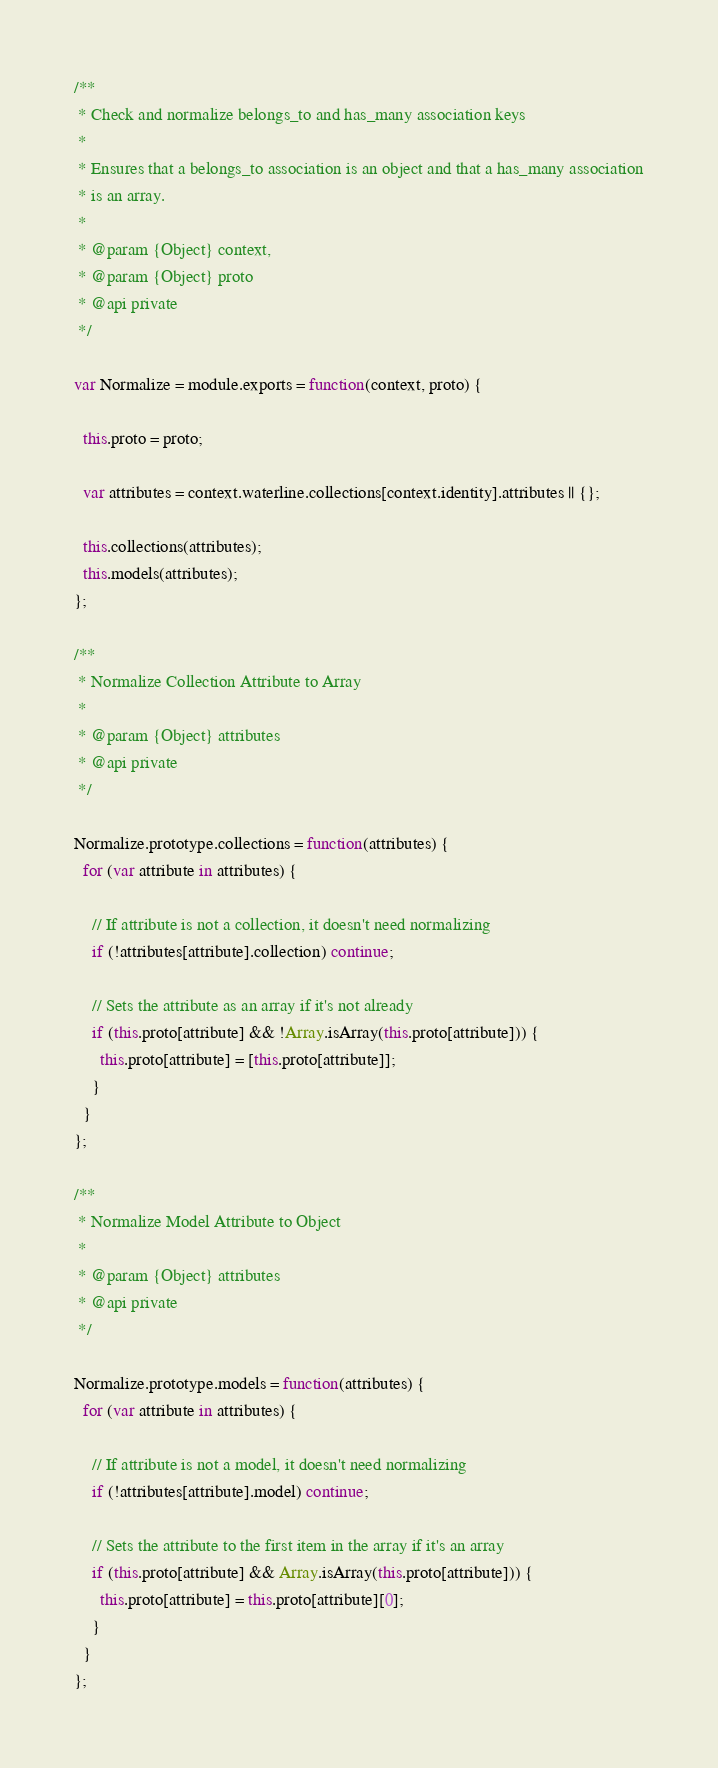Convert code to text. <code><loc_0><loc_0><loc_500><loc_500><_JavaScript_>
/**
 * Check and normalize belongs_to and has_many association keys
 *
 * Ensures that a belongs_to association is an object and that a has_many association
 * is an array.
 *
 * @param {Object} context,
 * @param {Object} proto
 * @api private
 */

var Normalize = module.exports = function(context, proto) {

  this.proto = proto;

  var attributes = context.waterline.collections[context.identity].attributes || {};

  this.collections(attributes);
  this.models(attributes);
};

/**
 * Normalize Collection Attribute to Array
 *
 * @param {Object} attributes
 * @api private
 */

Normalize.prototype.collections = function(attributes) {
  for (var attribute in attributes) {

    // If attribute is not a collection, it doesn't need normalizing
    if (!attributes[attribute].collection) continue;

    // Sets the attribute as an array if it's not already
    if (this.proto[attribute] && !Array.isArray(this.proto[attribute])) {
      this.proto[attribute] = [this.proto[attribute]];
    }
  }
};

/**
 * Normalize Model Attribute to Object
 *
 * @param {Object} attributes
 * @api private
 */

Normalize.prototype.models = function(attributes) {
  for (var attribute in attributes) {

    // If attribute is not a model, it doesn't need normalizing
    if (!attributes[attribute].model) continue;

    // Sets the attribute to the first item in the array if it's an array
    if (this.proto[attribute] && Array.isArray(this.proto[attribute])) {
      this.proto[attribute] = this.proto[attribute][0];
    }
  }
};
</code> 